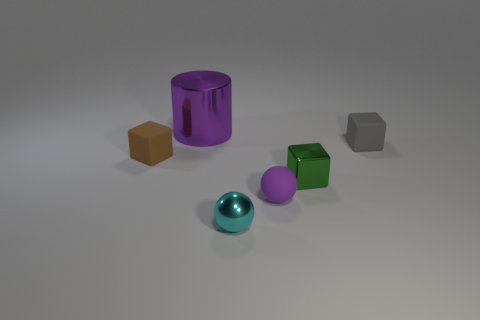The tiny thing that is the same color as the large cylinder is what shape?
Provide a succinct answer. Sphere. Is there a matte thing that has the same color as the big shiny cylinder?
Your answer should be compact. Yes. What is the size of the green cube that is the same material as the cyan sphere?
Your answer should be very brief. Small. Is there anything else that is the same color as the small shiny cube?
Your response must be concise. No. What color is the thing behind the gray thing?
Ensure brevity in your answer.  Purple. Are there any rubber objects that are to the right of the purple thing left of the rubber object in front of the brown rubber block?
Offer a very short reply. Yes. Is the number of blocks that are in front of the brown rubber object greater than the number of big rubber cubes?
Make the answer very short. Yes. Is the shape of the object that is in front of the small purple rubber object the same as  the tiny purple matte thing?
Your answer should be very brief. Yes. How many things are small green shiny objects or tiny things on the left side of the large purple metal object?
Make the answer very short. 2. There is a metallic object that is on the right side of the large object and behind the cyan metal sphere; what size is it?
Offer a terse response. Small. 